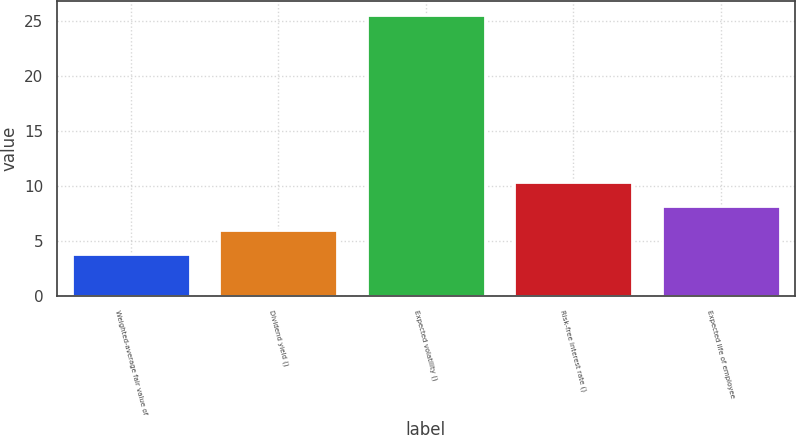Convert chart. <chart><loc_0><loc_0><loc_500><loc_500><bar_chart><fcel>Weighted-average fair value of<fcel>Dividend yield ()<fcel>Expected volatility ()<fcel>Risk-free interest rate ()<fcel>Expected life of employee<nl><fcel>3.82<fcel>5.99<fcel>25.49<fcel>10.33<fcel>8.16<nl></chart> 